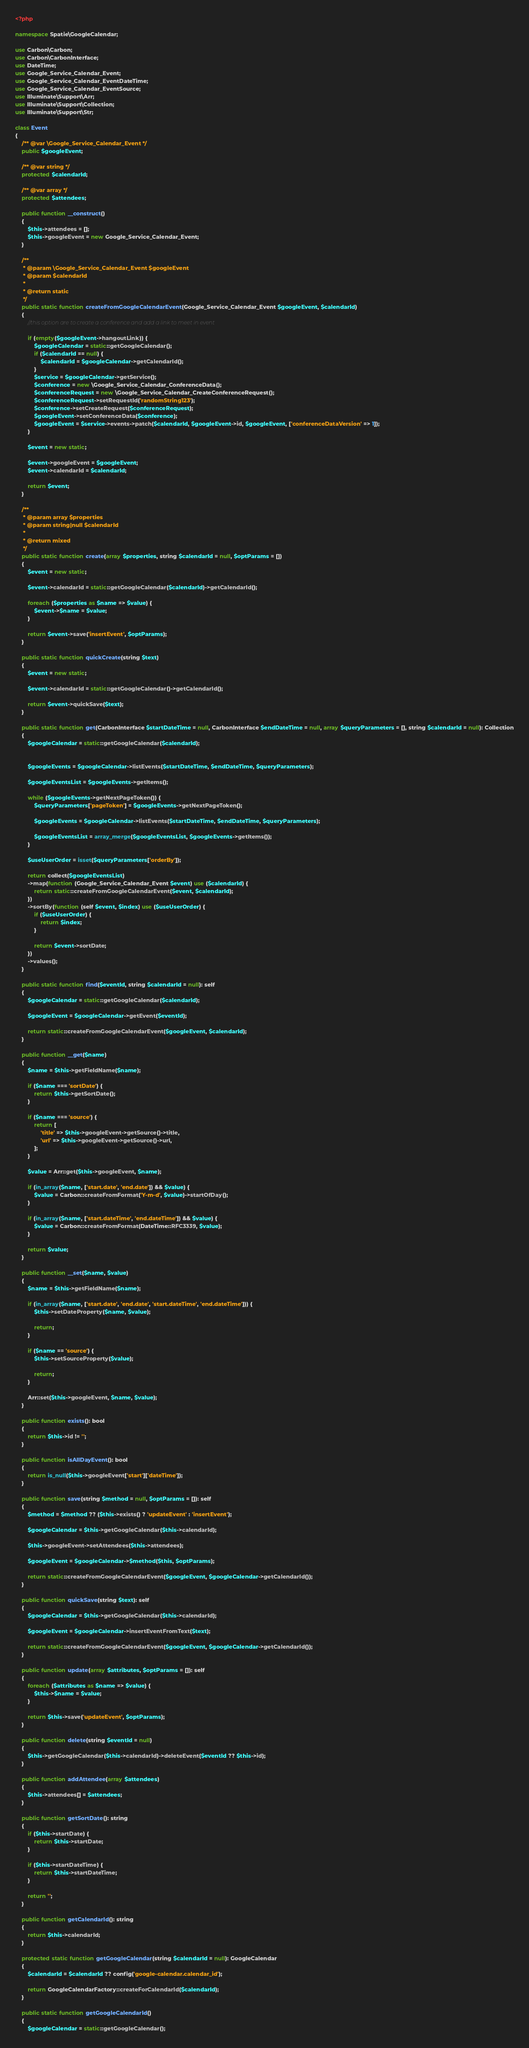Convert code to text. <code><loc_0><loc_0><loc_500><loc_500><_PHP_><?php

namespace Spatie\GoogleCalendar;

use Carbon\Carbon;
use Carbon\CarbonInterface;
use DateTime;
use Google_Service_Calendar_Event;
use Google_Service_Calendar_EventDateTime;
use Google_Service_Calendar_EventSource;
use Illuminate\Support\Arr;
use Illuminate\Support\Collection;
use Illuminate\Support\Str;

class Event
{
    /** @var \Google_Service_Calendar_Event */
    public $googleEvent;

    /** @var string */
    protected $calendarId;

    /** @var array */
    protected $attendees;

    public function __construct()
    {
        $this->attendees = [];
        $this->googleEvent = new Google_Service_Calendar_Event;
    }

    /**
     * @param \Google_Service_Calendar_Event $googleEvent
     * @param $calendarId
     *
     * @return static
     */
    public static function createFromGoogleCalendarEvent(Google_Service_Calendar_Event $googleEvent, $calendarId)
    {
        //this option are to create a conference and add a link to meet in event

        if (empty($googleEvent->hangoutLink)) {
            $googleCalendar = static::getGoogleCalendar();
            if ($calendarId == null) {
                $calendarId = $googleCalendar->getCalendarId();
            }
            $service = $googleCalendar->getService();
            $conference = new \Google_Service_Calendar_ConferenceData();
            $conferenceRequest = new \Google_Service_Calendar_CreateConferenceRequest();
            $conferenceRequest->setRequestId('randomString123');
            $conference->setCreateRequest($conferenceRequest);
            $googleEvent->setConferenceData($conference);
            $googleEvent = $service->events->patch($calendarId, $googleEvent->id, $googleEvent, ['conferenceDataVersion' => 1]);
        }

        $event = new static;

        $event->googleEvent = $googleEvent;
        $event->calendarId = $calendarId;

        return $event;
    }

    /**
     * @param array $properties
     * @param string|null $calendarId
     *
     * @return mixed
     */
    public static function create(array $properties, string $calendarId = null, $optParams = [])
    {
        $event = new static;

        $event->calendarId = static::getGoogleCalendar($calendarId)->getCalendarId();

        foreach ($properties as $name => $value) {
            $event->$name = $value;
        }

        return $event->save('insertEvent', $optParams);
    }

    public static function quickCreate(string $text)
    {
        $event = new static;

        $event->calendarId = static::getGoogleCalendar()->getCalendarId();

        return $event->quickSave($text);
    }

    public static function get(CarbonInterface $startDateTime = null, CarbonInterface $endDateTime = null, array $queryParameters = [], string $calendarId = null): Collection
    {
        $googleCalendar = static::getGoogleCalendar($calendarId);


        $googleEvents = $googleCalendar->listEvents($startDateTime, $endDateTime, $queryParameters);

        $googleEventsList = $googleEvents->getItems();

        while ($googleEvents->getNextPageToken()) {
            $queryParameters['pageToken'] = $googleEvents->getNextPageToken();

            $googleEvents = $googleCalendar->listEvents($startDateTime, $endDateTime, $queryParameters);

            $googleEventsList = array_merge($googleEventsList, $googleEvents->getItems());
        }

        $useUserOrder = isset($queryParameters['orderBy']);

        return collect($googleEventsList)
        ->map(function (Google_Service_Calendar_Event $event) use ($calendarId) {
            return static::createFromGoogleCalendarEvent($event, $calendarId);
        })
        ->sortBy(function (self $event, $index) use ($useUserOrder) {
            if ($useUserOrder) {
                return $index;
            }

            return $event->sortDate;
        })
        ->values();
    }

    public static function find($eventId, string $calendarId = null): self
    {
        $googleCalendar = static::getGoogleCalendar($calendarId);

        $googleEvent = $googleCalendar->getEvent($eventId);

        return static::createFromGoogleCalendarEvent($googleEvent, $calendarId);
    }

    public function __get($name)
    {
        $name = $this->getFieldName($name);

        if ($name === 'sortDate') {
            return $this->getSortDate();
        }

        if ($name === 'source') {
            return [
                'title' => $this->googleEvent->getSource()->title,
                'url' => $this->googleEvent->getSource()->url,
            ];
        }

        $value = Arr::get($this->googleEvent, $name);

        if (in_array($name, ['start.date', 'end.date']) && $value) {
            $value = Carbon::createFromFormat('Y-m-d', $value)->startOfDay();
        }

        if (in_array($name, ['start.dateTime', 'end.dateTime']) && $value) {
            $value = Carbon::createFromFormat(DateTime::RFC3339, $value);
        }

        return $value;
    }

    public function __set($name, $value)
    {
        $name = $this->getFieldName($name);

        if (in_array($name, ['start.date', 'end.date', 'start.dateTime', 'end.dateTime'])) {
            $this->setDateProperty($name, $value);

            return;
        }

        if ($name == 'source') {
            $this->setSourceProperty($value);

            return;
        }

        Arr::set($this->googleEvent, $name, $value);
    }

    public function exists(): bool
    {
        return $this->id != '';
    }

    public function isAllDayEvent(): bool
    {
        return is_null($this->googleEvent['start']['dateTime']);
    }

    public function save(string $method = null, $optParams = []): self
    {
        $method = $method ?? ($this->exists() ? 'updateEvent' : 'insertEvent');

        $googleCalendar = $this->getGoogleCalendar($this->calendarId);

        $this->googleEvent->setAttendees($this->attendees);

        $googleEvent = $googleCalendar->$method($this, $optParams);

        return static::createFromGoogleCalendarEvent($googleEvent, $googleCalendar->getCalendarId());
    }

    public function quickSave(string $text): self
    {
        $googleCalendar = $this->getGoogleCalendar($this->calendarId);

        $googleEvent = $googleCalendar->insertEventFromText($text);

        return static::createFromGoogleCalendarEvent($googleEvent, $googleCalendar->getCalendarId());
    }

    public function update(array $attributes, $optParams = []): self
    {
        foreach ($attributes as $name => $value) {
            $this->$name = $value;
        }

        return $this->save('updateEvent', $optParams);
    }

    public function delete(string $eventId = null)
    {
        $this->getGoogleCalendar($this->calendarId)->deleteEvent($eventId ?? $this->id);
    }

    public function addAttendee(array $attendees)
    {
        $this->attendees[] = $attendees;
    }

    public function getSortDate(): string
    {
        if ($this->startDate) {
            return $this->startDate;
        }

        if ($this->startDateTime) {
            return $this->startDateTime;
        }

        return '';
    }

    public function getCalendarId(): string
    {
        return $this->calendarId;
    }

    protected static function getGoogleCalendar(string $calendarId = null): GoogleCalendar
    {
        $calendarId = $calendarId ?? config('google-calendar.calendar_id');

        return GoogleCalendarFactory::createForCalendarId($calendarId);
    }

    public static function getGoogleCalendarId()
    {
        $googleCalendar = static::getGoogleCalendar();
</code> 